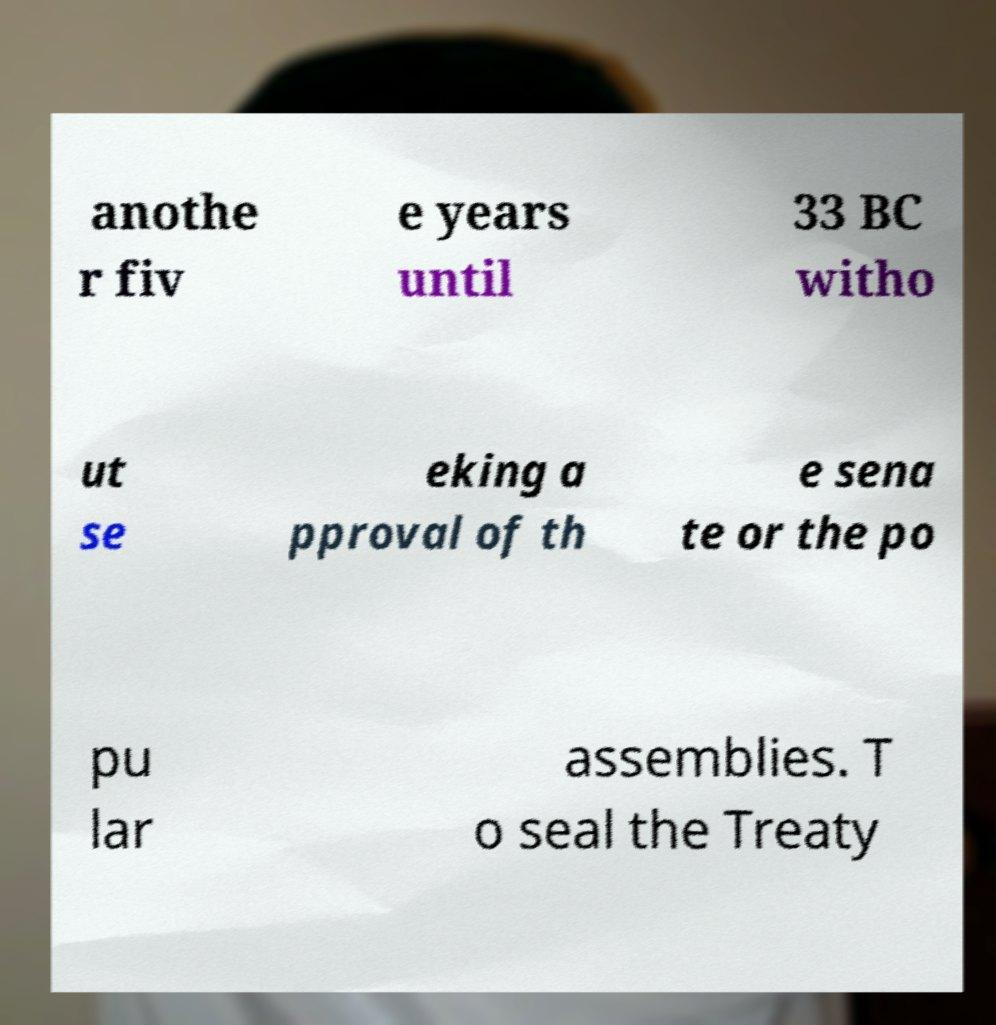Please read and relay the text visible in this image. What does it say? anothe r fiv e years until 33 BC witho ut se eking a pproval of th e sena te or the po pu lar assemblies. T o seal the Treaty 